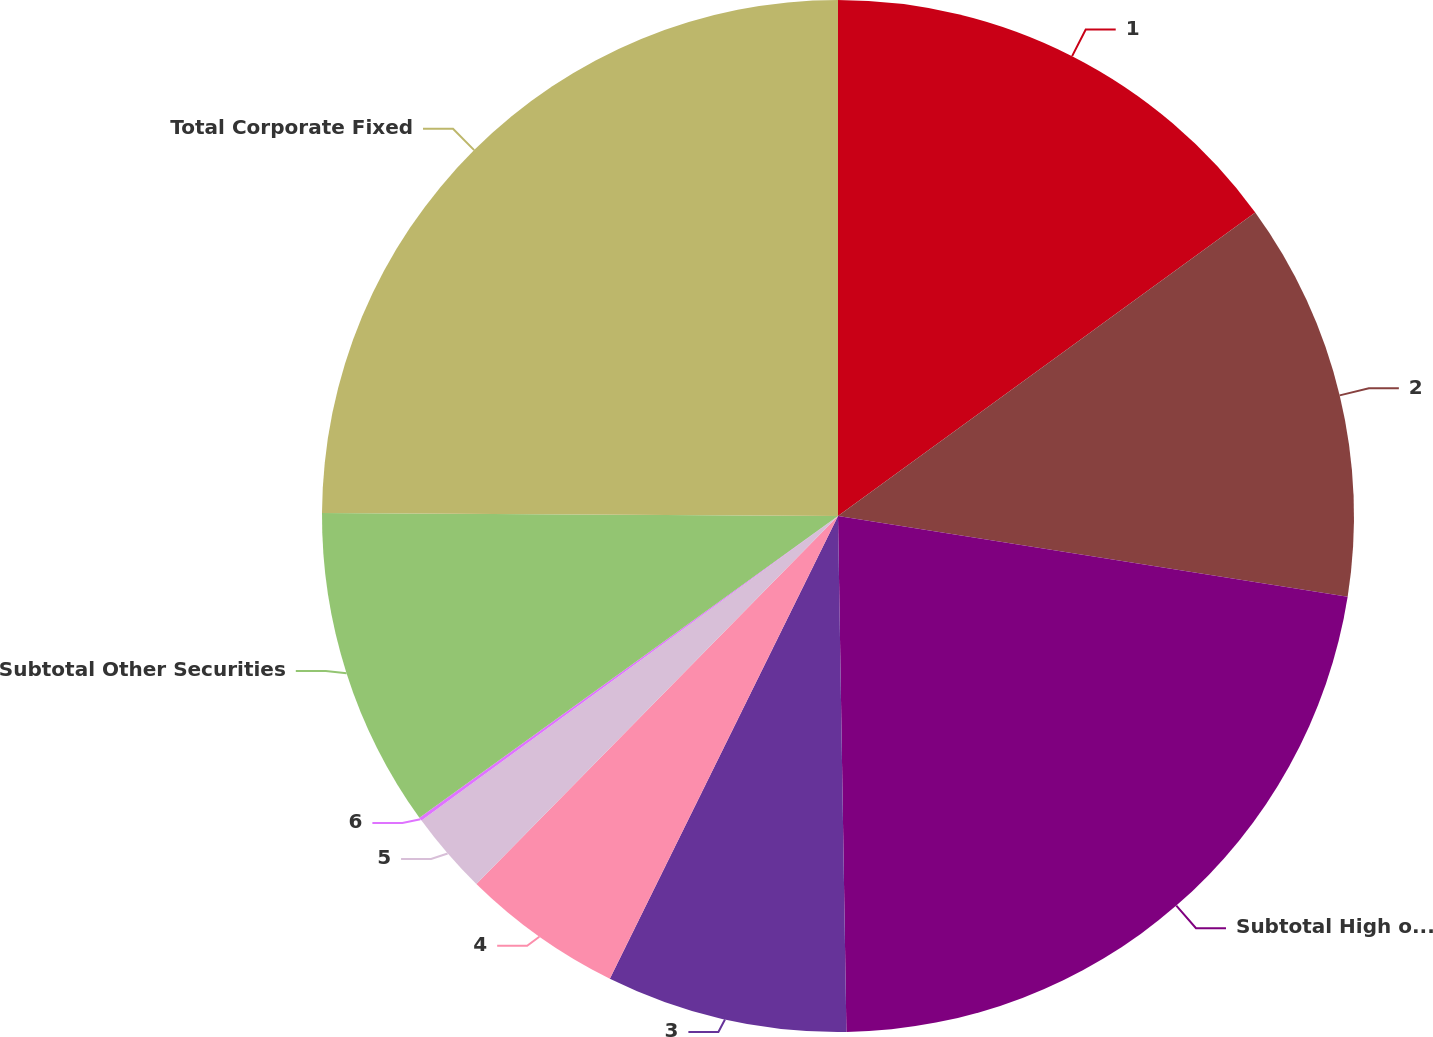Convert chart. <chart><loc_0><loc_0><loc_500><loc_500><pie_chart><fcel>1<fcel>2<fcel>Subtotal High or Highest<fcel>3<fcel>4<fcel>5<fcel>6<fcel>Subtotal Other Securities<fcel>Total Corporate Fixed<nl><fcel>14.99%<fcel>12.51%<fcel>22.24%<fcel>7.55%<fcel>5.07%<fcel>2.59%<fcel>0.11%<fcel>10.03%<fcel>24.91%<nl></chart> 